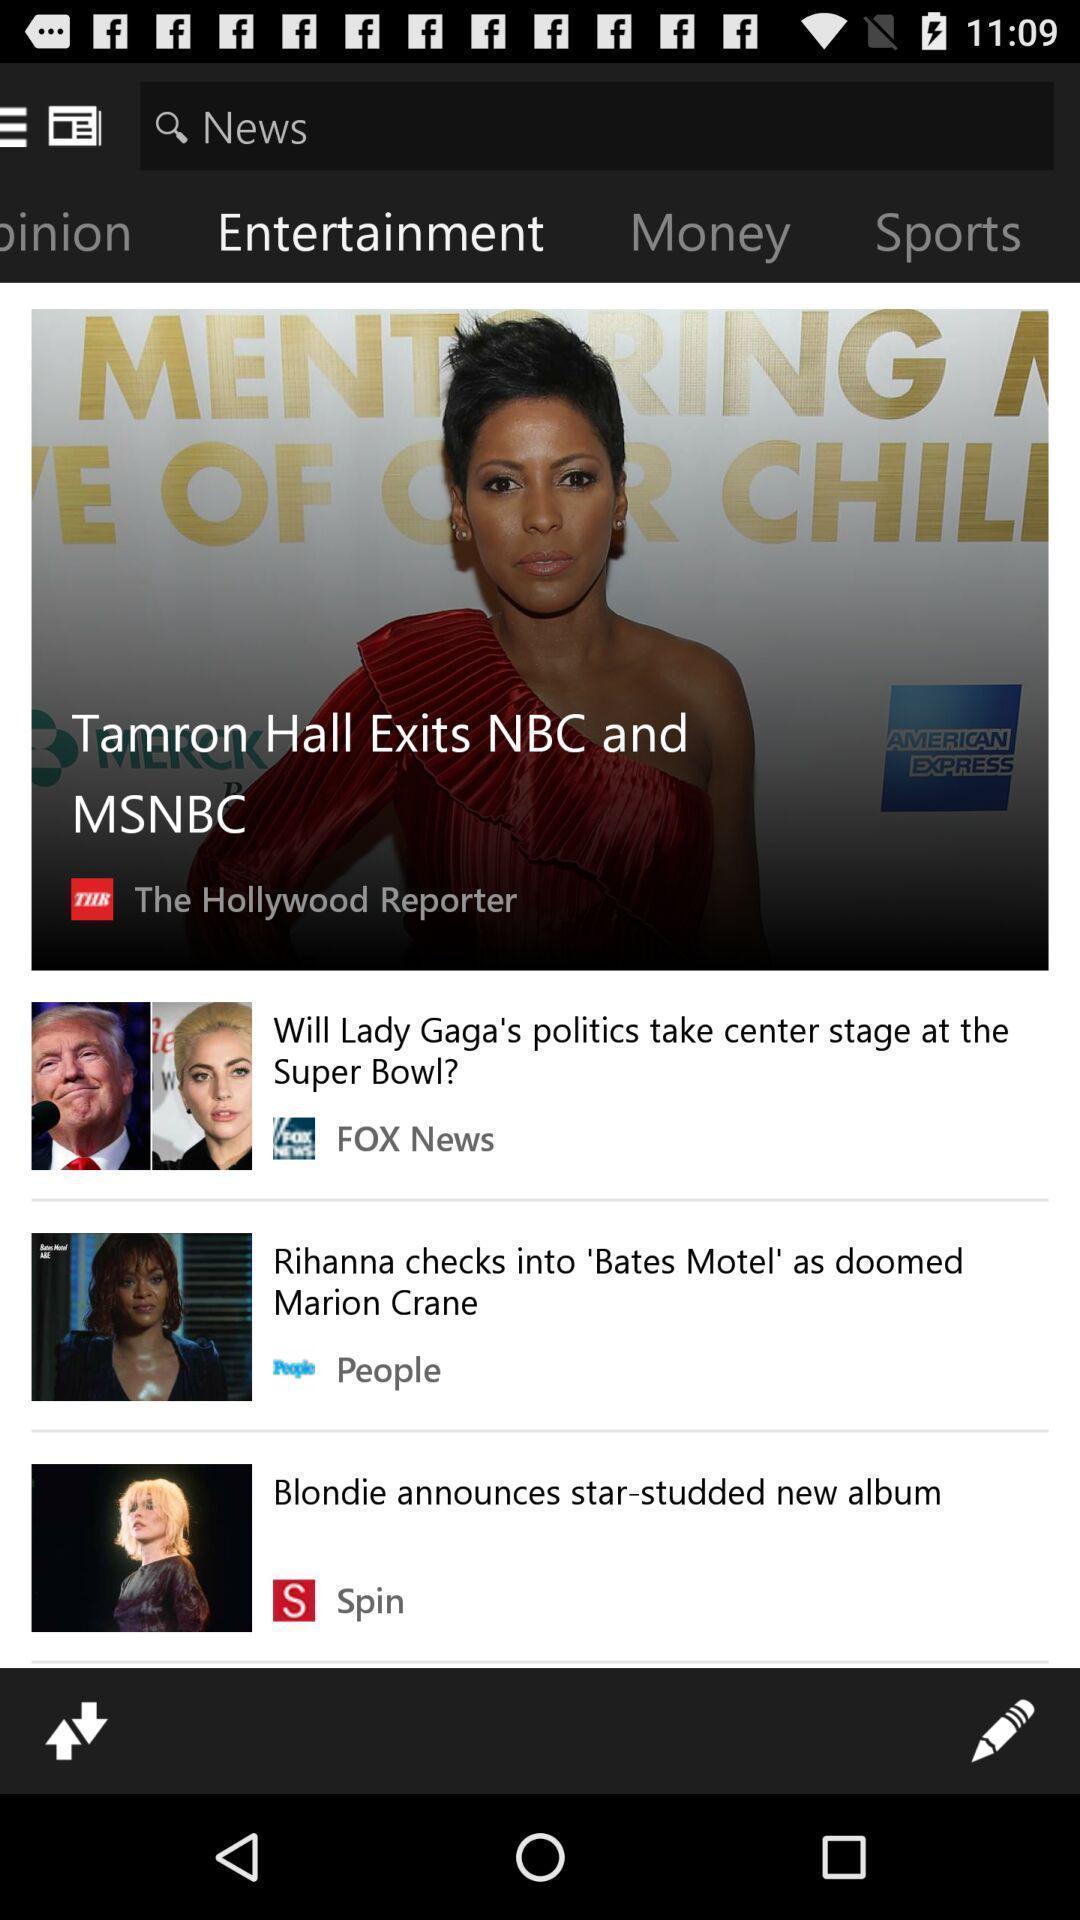Explain the elements present in this screenshot. Page showing breaking news. 